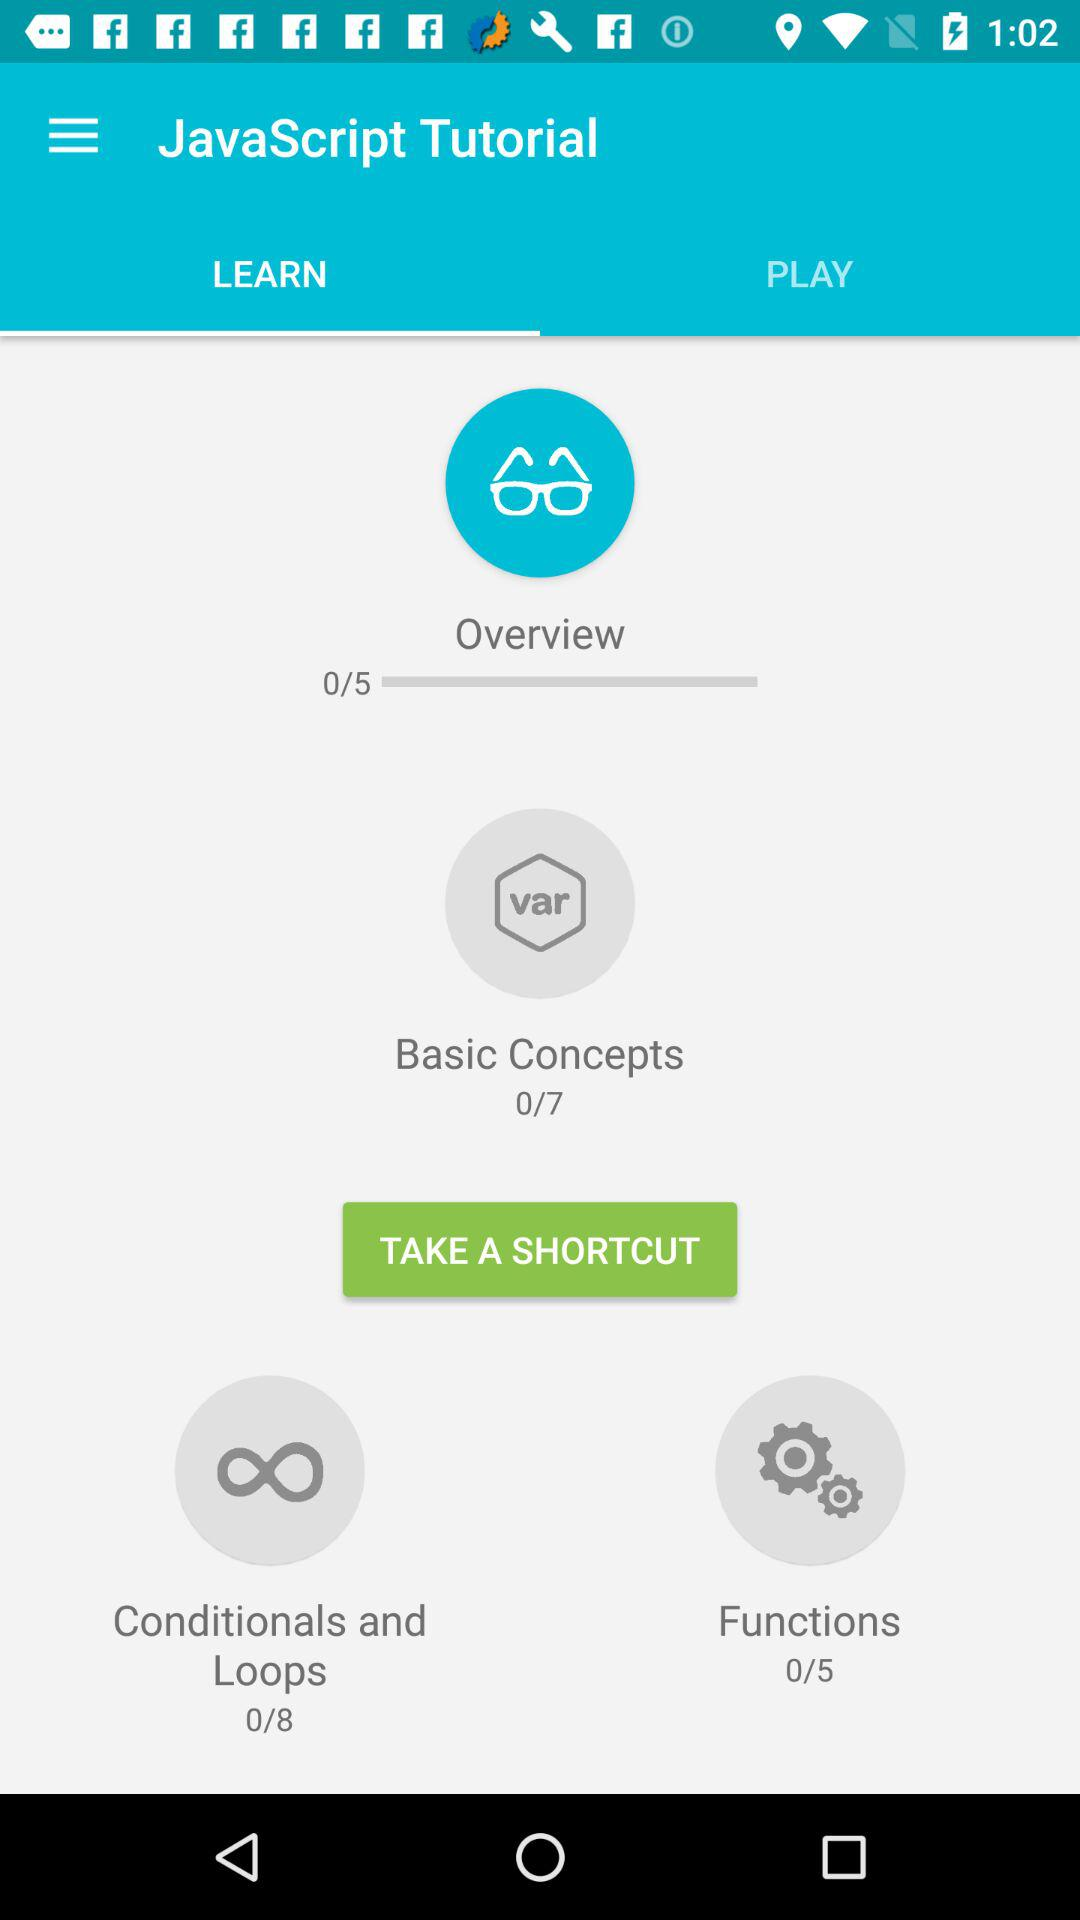Which topic includes eight chapters? The topic that includes eight chapters is "Conditionals and Loops". 